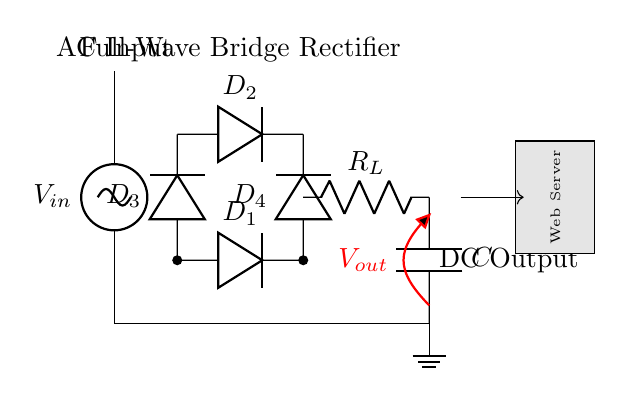What type of rectifier is shown? The circuit depicts a full-wave bridge rectifier, which utilizes four diodes to convert AC input to DC output effectively.
Answer: full-wave bridge rectifier What is the role of the capacitor in this circuit? The capacitor smooths the DC output voltage by storing energy and releasing it to reduce voltage fluctuations from the rectification process.
Answer: smooth the output How many diodes are used in this rectifier? There are four diodes connected in a bridge configuration to allow current to flow during both halves of the AC input cycle.
Answer: four What is the voltage across the load resistor? The output voltage across the load resistor is the DC voltage provided by the rectifier after rectification and smoothing by the capacitor.
Answer: V out Which components are responsible for converting AC to DC? The four diodes labeled D1, D2, D3, and D4 are responsible for converting the alternating current from the input to direct current at the output.
Answer: diodes What type of load is connected at the output? The load connected at the output is a resistor, indicated as R_L, which represents the device powered by the rectifier's output.
Answer: resistor 